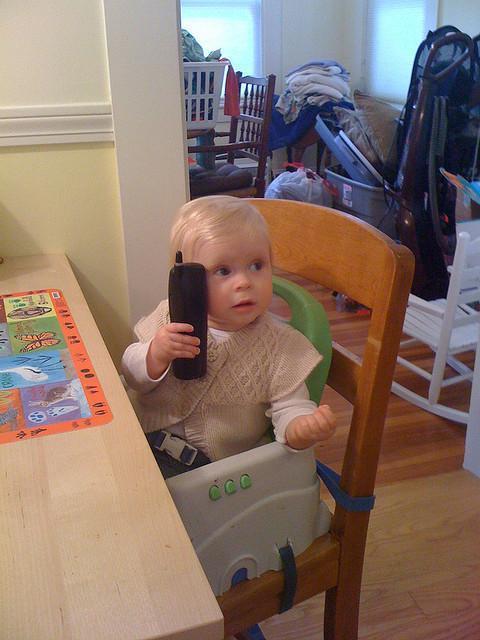How many chairs are in the photo?
Give a very brief answer. 3. 